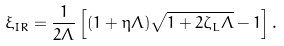<formula> <loc_0><loc_0><loc_500><loc_500>\xi _ { I R } = \frac { 1 } { 2 \Lambda } \left [ ( 1 + \eta \Lambda ) \sqrt { 1 + 2 \zeta _ { L } \Lambda } - 1 \right ] .</formula> 